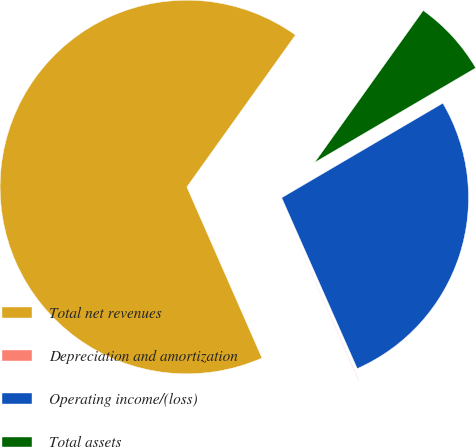Convert chart to OTSL. <chart><loc_0><loc_0><loc_500><loc_500><pie_chart><fcel>Total net revenues<fcel>Depreciation and amortization<fcel>Operating income/(loss)<fcel>Total assets<nl><fcel>66.46%<fcel>0.04%<fcel>26.82%<fcel>6.68%<nl></chart> 